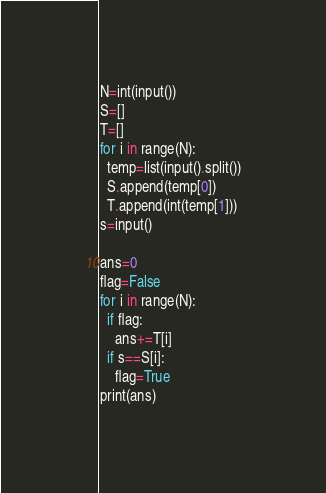Convert code to text. <code><loc_0><loc_0><loc_500><loc_500><_Python_>N=int(input())
S=[]
T=[]
for i in range(N):
  temp=list(input().split())
  S.append(temp[0])
  T.append(int(temp[1]))
s=input()

ans=0
flag=False
for i in range(N):
  if flag:
    ans+=T[i]
  if s==S[i]:
    flag=True
print(ans)</code> 